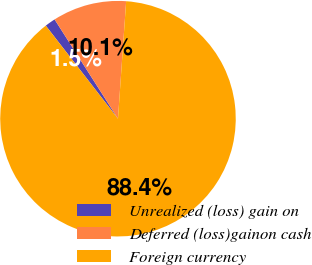Convert chart. <chart><loc_0><loc_0><loc_500><loc_500><pie_chart><fcel>Unrealized (loss) gain on<fcel>Deferred (loss)gainon cash<fcel>Foreign currency<nl><fcel>1.46%<fcel>10.15%<fcel>88.39%<nl></chart> 